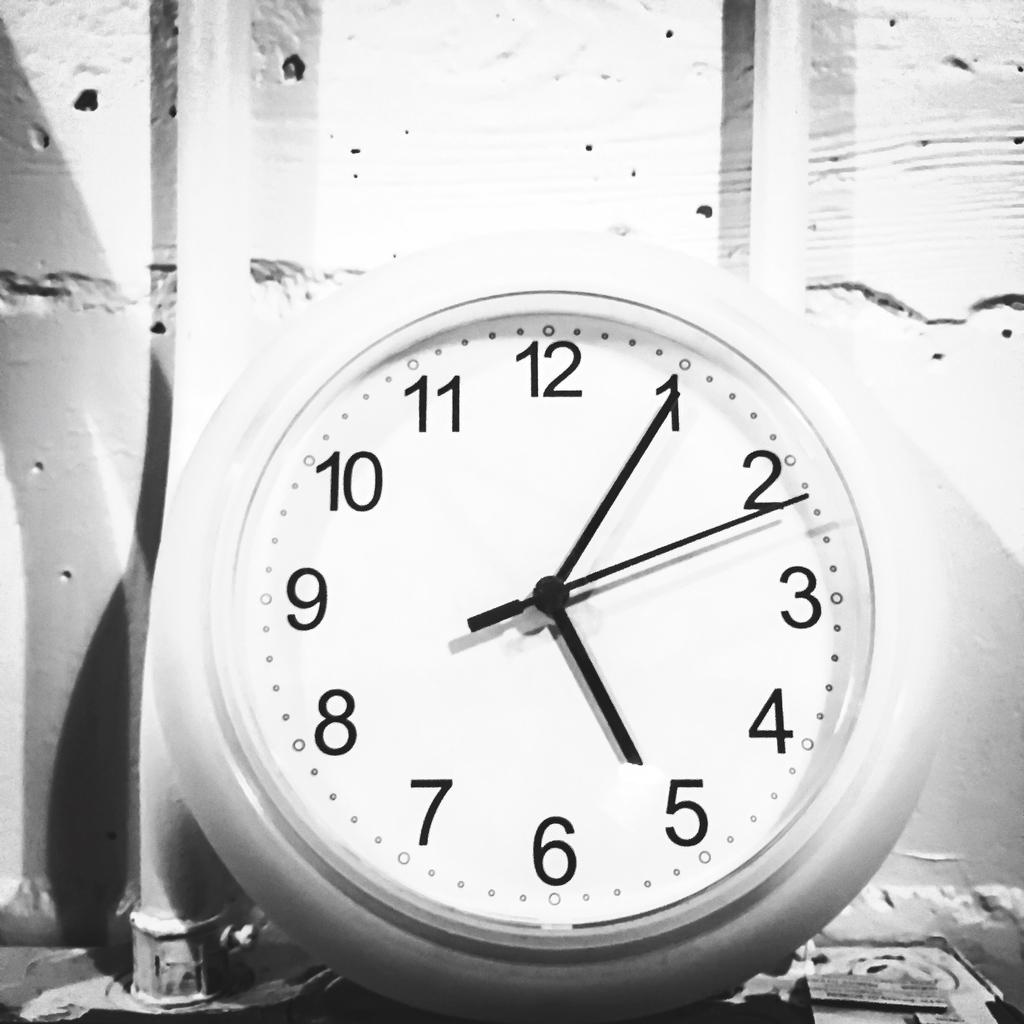<image>
Give a short and clear explanation of the subsequent image. A round white clock reads that it is 5:05. 